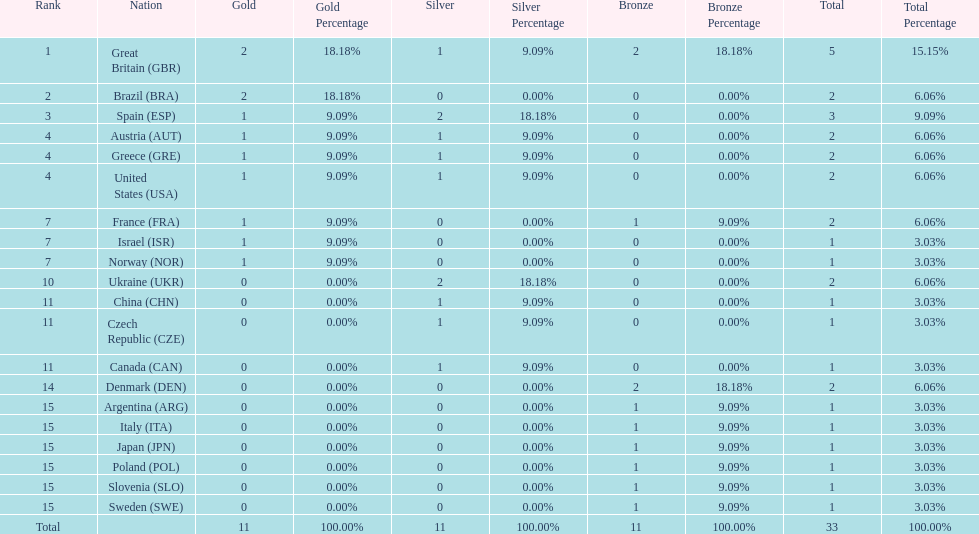Who won more gold medals than spain? Great Britain (GBR), Brazil (BRA). 